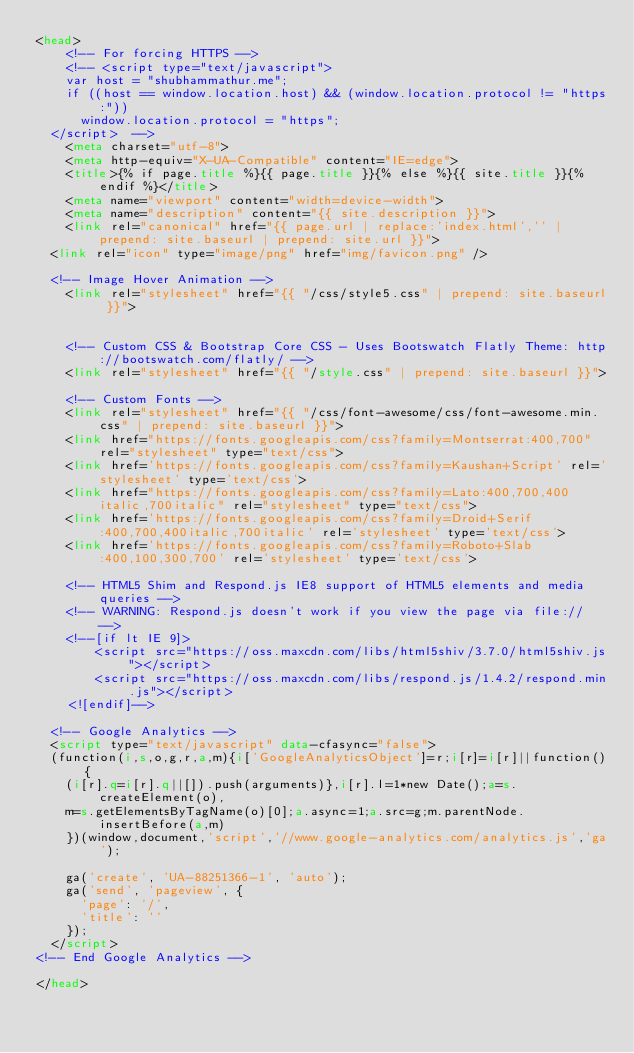Convert code to text. <code><loc_0><loc_0><loc_500><loc_500><_HTML_><head>
    <!-- For forcing HTTPS -->
 	  <!-- <script type="text/javascript">
 		var host = "shubhammathur.me";
 		if ((host == window.location.host) && (window.location.protocol != "https:"))
 			window.location.protocol = "https";
 	</script>  -->
    <meta charset="utf-8">
    <meta http-equiv="X-UA-Compatible" content="IE=edge">
    <title>{% if page.title %}{{ page.title }}{% else %}{{ site.title }}{% endif %}</title>
    <meta name="viewport" content="width=device-width">
    <meta name="description" content="{{ site.description }}">
    <link rel="canonical" href="{{ page.url | replace:'index.html','' | prepend: site.baseurl | prepend: site.url }}">
	<link rel="icon" type="image/png" href="img/favicon.png" />

	<!-- Image Hover Animation -->
    <link rel="stylesheet" href="{{ "/css/style5.css" | prepend: site.baseurl }}">
    

    <!-- Custom CSS & Bootstrap Core CSS - Uses Bootswatch Flatly Theme: http://bootswatch.com/flatly/ -->
    <link rel="stylesheet" href="{{ "/style.css" | prepend: site.baseurl }}">

    <!-- Custom Fonts -->
    <link rel="stylesheet" href="{{ "/css/font-awesome/css/font-awesome.min.css" | prepend: site.baseurl }}">
    <link href="https://fonts.googleapis.com/css?family=Montserrat:400,700" rel="stylesheet" type="text/css">
    <link href='https://fonts.googleapis.com/css?family=Kaushan+Script' rel='stylesheet' type='text/css'>
    <link href="https://fonts.googleapis.com/css?family=Lato:400,700,400italic,700italic" rel="stylesheet" type="text/css">
    <link href='https://fonts.googleapis.com/css?family=Droid+Serif:400,700,400italic,700italic' rel='stylesheet' type='text/css'>
    <link href='https://fonts.googleapis.com/css?family=Roboto+Slab:400,100,300,700' rel='stylesheet' type='text/css'>

    <!-- HTML5 Shim and Respond.js IE8 support of HTML5 elements and media queries -->
    <!-- WARNING: Respond.js doesn't work if you view the page via file:// -->
    <!--[if lt IE 9]>
        <script src="https://oss.maxcdn.com/libs/html5shiv/3.7.0/html5shiv.js"></script>
        <script src="https://oss.maxcdn.com/libs/respond.js/1.4.2/respond.min.js"></script>
    <![endif]-->
			
 	<!-- Google Analytics -->
 	<script type="text/javascript" data-cfasync="false">
 	(function(i,s,o,g,r,a,m){i['GoogleAnalyticsObject']=r;i[r]=i[r]||function(){
 		(i[r].q=i[r].q||[]).push(arguments)},i[r].l=1*new Date();a=s.createElement(o),
 		m=s.getElementsByTagName(o)[0];a.async=1;a.src=g;m.parentNode.insertBefore(a,m)
 		})(window,document,'script','//www.google-analytics.com/analytics.js','ga');
 
 		ga('create', 'UA-88251366-1', 'auto');
 		ga('send', 'pageview', {
 		  'page': '/',
 		  'title': ''
 		});
 	</script>
<!-- End Google Analytics -->

</head>
</code> 